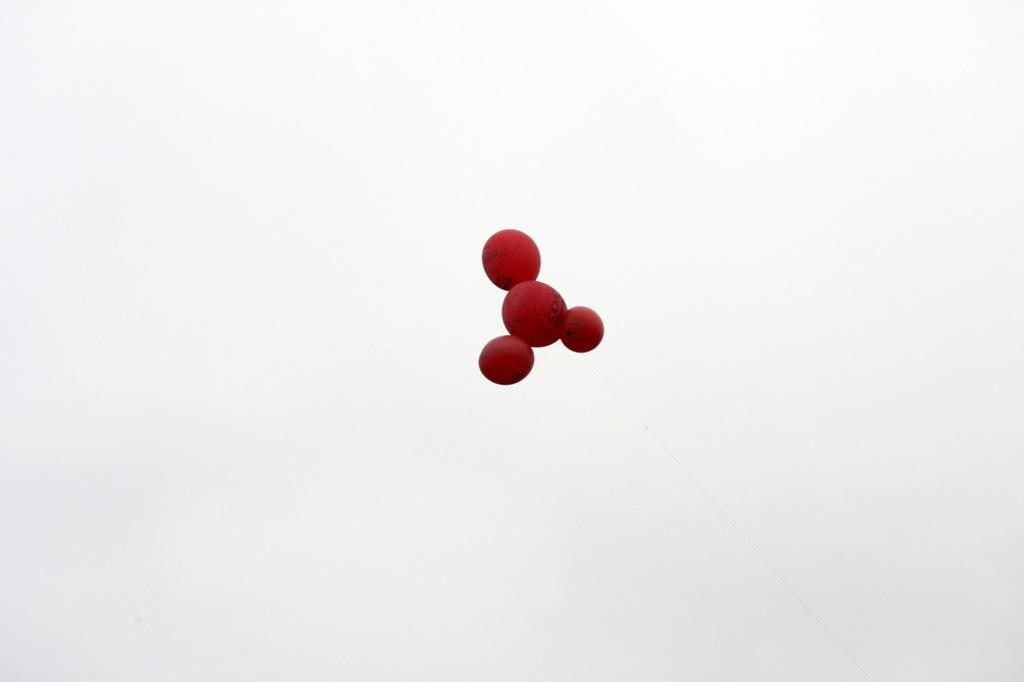What is the main subject of the image? The main subject of the image is a brown color animated molecule of an object. What color is the background of the image? The background of the image is white. Can you tell me how many rivers are visible in the image? There are no rivers present in the image; it features a brown color animated molecule of an object against a white background. What type of dress is the judge wearing in the image? There is no judge or dress present in the image. 